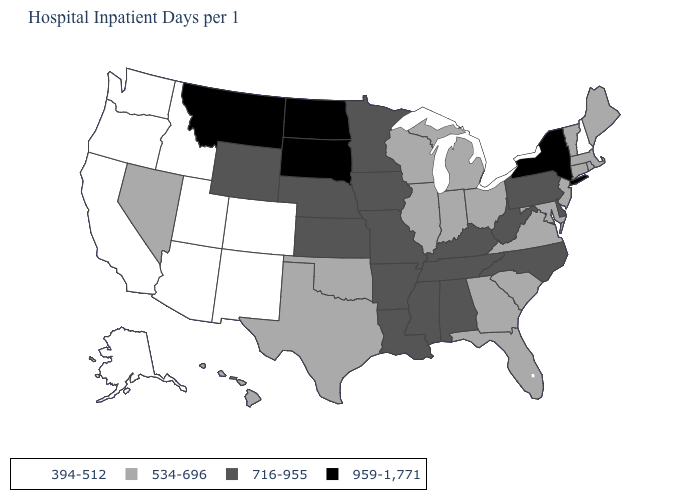Name the states that have a value in the range 716-955?
Be succinct. Alabama, Arkansas, Delaware, Iowa, Kansas, Kentucky, Louisiana, Minnesota, Mississippi, Missouri, Nebraska, North Carolina, Pennsylvania, Tennessee, West Virginia, Wyoming. What is the value of North Carolina?
Quick response, please. 716-955. What is the value of Montana?
Be succinct. 959-1,771. What is the value of North Dakota?
Write a very short answer. 959-1,771. Does California have the lowest value in the USA?
Quick response, please. Yes. Does the first symbol in the legend represent the smallest category?
Short answer required. Yes. Name the states that have a value in the range 534-696?
Be succinct. Connecticut, Florida, Georgia, Hawaii, Illinois, Indiana, Maine, Maryland, Massachusetts, Michigan, Nevada, New Jersey, Ohio, Oklahoma, Rhode Island, South Carolina, Texas, Vermont, Virginia, Wisconsin. Which states have the lowest value in the USA?
Be succinct. Alaska, Arizona, California, Colorado, Idaho, New Hampshire, New Mexico, Oregon, Utah, Washington. What is the highest value in states that border Arkansas?
Give a very brief answer. 716-955. Among the states that border Delaware , which have the lowest value?
Keep it brief. Maryland, New Jersey. Does South Carolina have the highest value in the South?
Keep it brief. No. Name the states that have a value in the range 394-512?
Be succinct. Alaska, Arizona, California, Colorado, Idaho, New Hampshire, New Mexico, Oregon, Utah, Washington. Name the states that have a value in the range 394-512?
Write a very short answer. Alaska, Arizona, California, Colorado, Idaho, New Hampshire, New Mexico, Oregon, Utah, Washington. Name the states that have a value in the range 959-1,771?
Concise answer only. Montana, New York, North Dakota, South Dakota. Which states hav the highest value in the Northeast?
Keep it brief. New York. 